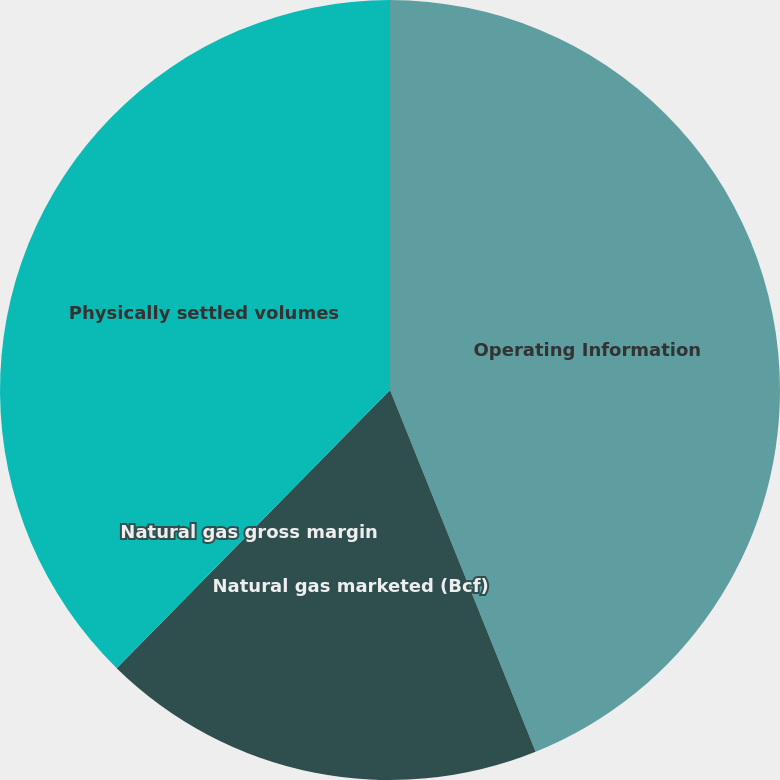Convert chart. <chart><loc_0><loc_0><loc_500><loc_500><pie_chart><fcel>Operating Information<fcel>Natural gas marketed (Bcf)<fcel>Natural gas gross margin<fcel>Physically settled volumes<nl><fcel>43.91%<fcel>18.45%<fcel>0.0%<fcel>37.64%<nl></chart> 